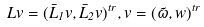Convert formula to latex. <formula><loc_0><loc_0><loc_500><loc_500>L v = ( \bar { L } _ { 1 } v , \bar { L } _ { 2 } v ) ^ { t r } , v = ( \tilde { \omega } , w ) ^ { t r }</formula> 